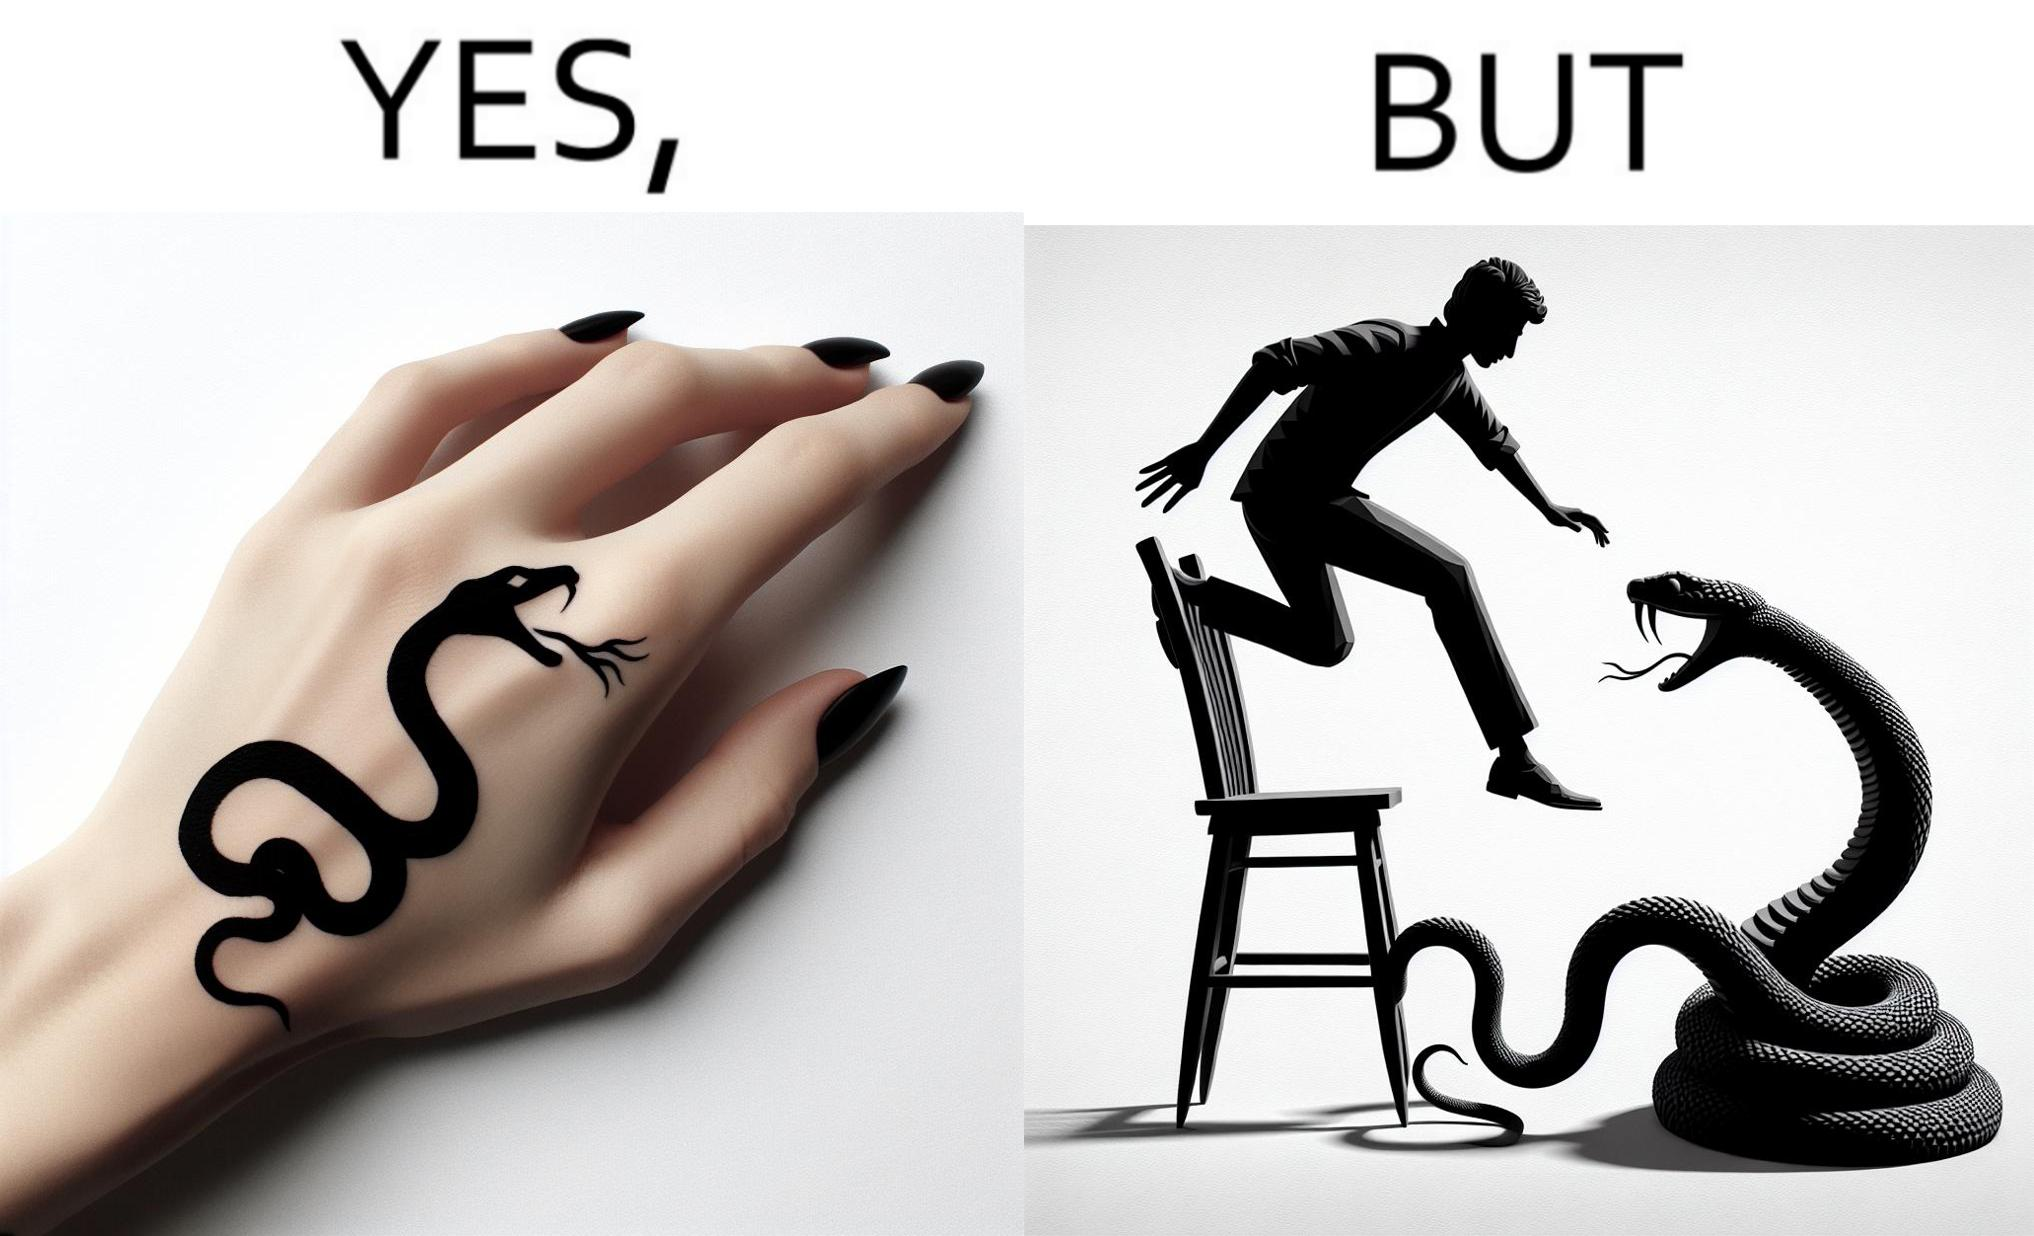Would you classify this image as satirical? Yes, this image is satirical. 